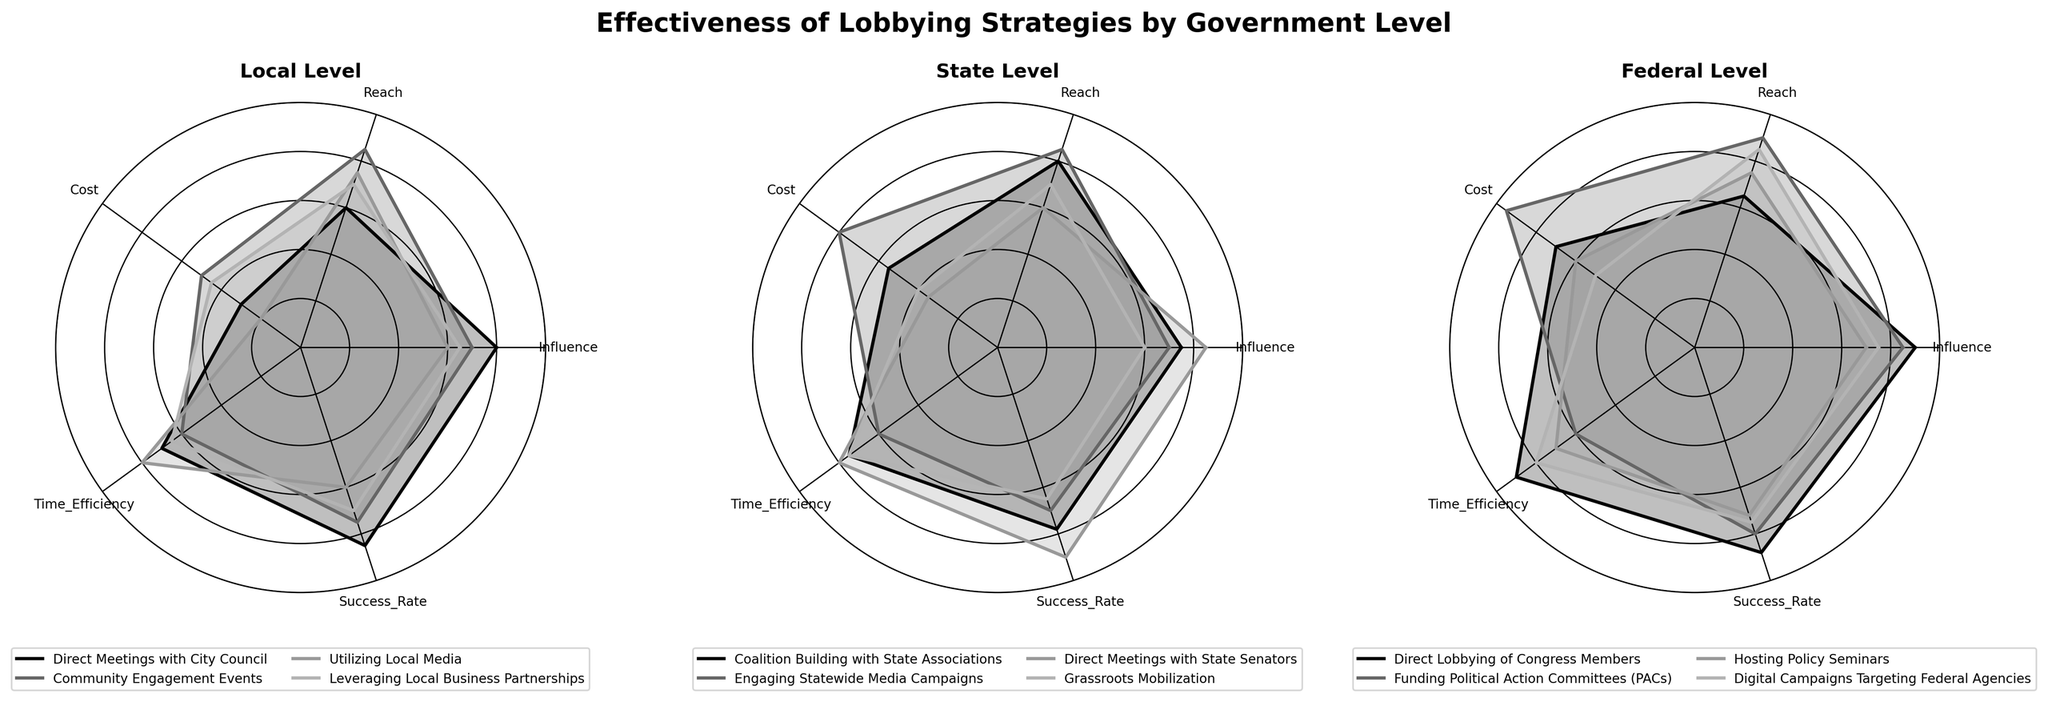What's the title of the figure? The title is displayed prominently at the top of the figure in bold and larger font compared to other text.
Answer: Effectiveness of Lobbying Strategies by Government Level How many different government levels are compared in the figure? The figure has three subplots, each representing a different government level.
Answer: Three Which lobbying strategy has the highest influence at the Local level? In the Local level subplot, the strategy with the highest value on the Influence axis is "Direct Meetings with City Council."
Answer: Direct Meetings with City Council Which strategy has the lowest cost at the Federal level? In the Federal subplot, comparing the values on the Cost axis, "Digital Campaigns Targeting Federal Agencies" has the lowest cost.
Answer: Digital Campaigns Targeting Federal Agencies What is the success rate of Direct Meetings with State Senators at the State level? In the State subplot, the line for "Direct Meetings with State Senators" reaches the highest point on the Success_Rate axis.
Answer: 90 Which government level has the highest average reach for its strategies? Calculate the average reach for strategies at each level by adding their reach values and dividing by the number of strategies. The State level has:
(80+85+60+70)/4 = 73.75
The Local level has:
(60+85+75+70)/4 = 72.5
The Federal level has:
(65+90+75+85)/4 = 78.75
The Federal level has the highest average reach.
Answer: Federal Which lobbying strategy is the most time-efficient at the Federal level? In the Federal subplot, "Direct Lobbying of Congress Members" reaches the highest point on the Time_Efficiency axis.
Answer: Direct Lobbying of Congress Members How does the cost of Funding Political Action Committees (PACs) compare to Engaging Statewide Media Campaigns? Compare the values on the Cost axis for these strategies in their respective subplots. PACs has a cost of 95 and Engaging Statewide Media Campaigns has a cost of 80.
Answer: PACs costs more Which strategy has a better success rate: Leveraging Local Business Partnerships or Hosting Policy Seminars? Compare the values on the Success_Rate axis for these strategies in their respective subplots. Leveraging Local Business Partnerships has a success rate of 70, while Hosting Policy Seminars has a success rate of 72.
Answer: Hosting Policy Seminars 